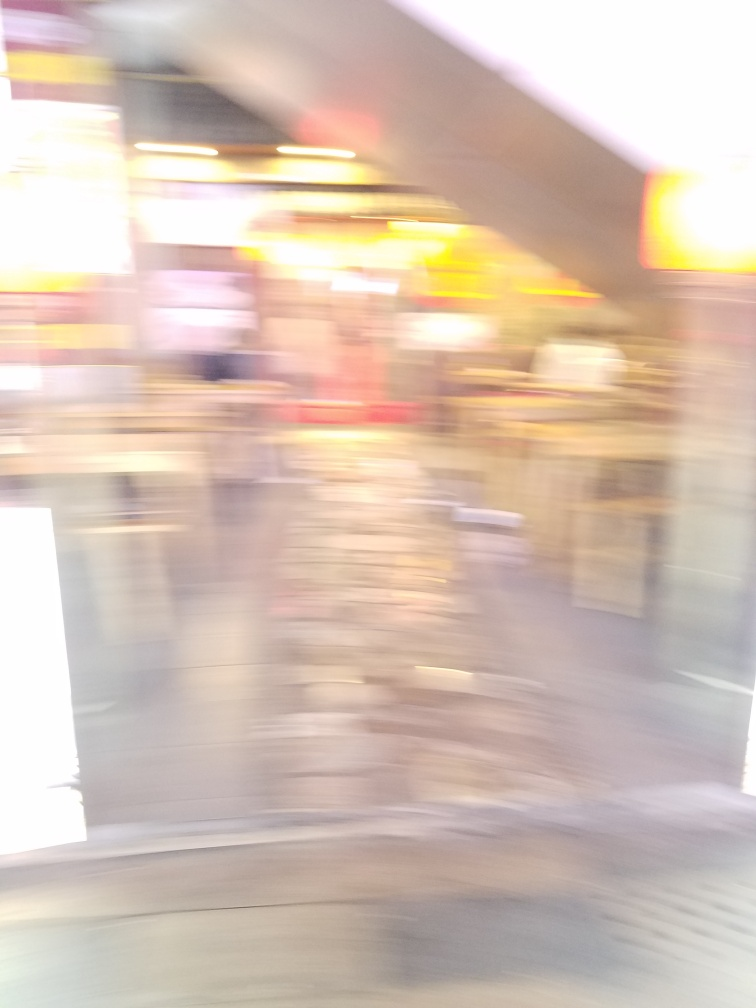Can you describe the colors and shapes you can distinguish in the blurred image? Despite the blurriness, we can discern a vibrant palette with warm tones like yellow and red, interspersed with cooler shades of blue and gray. Shapes are indistinct, but there appears to be elongated vertical streaks and soft, rounded forms that might indicate the presence of lights and possibly people or objects in motion. 